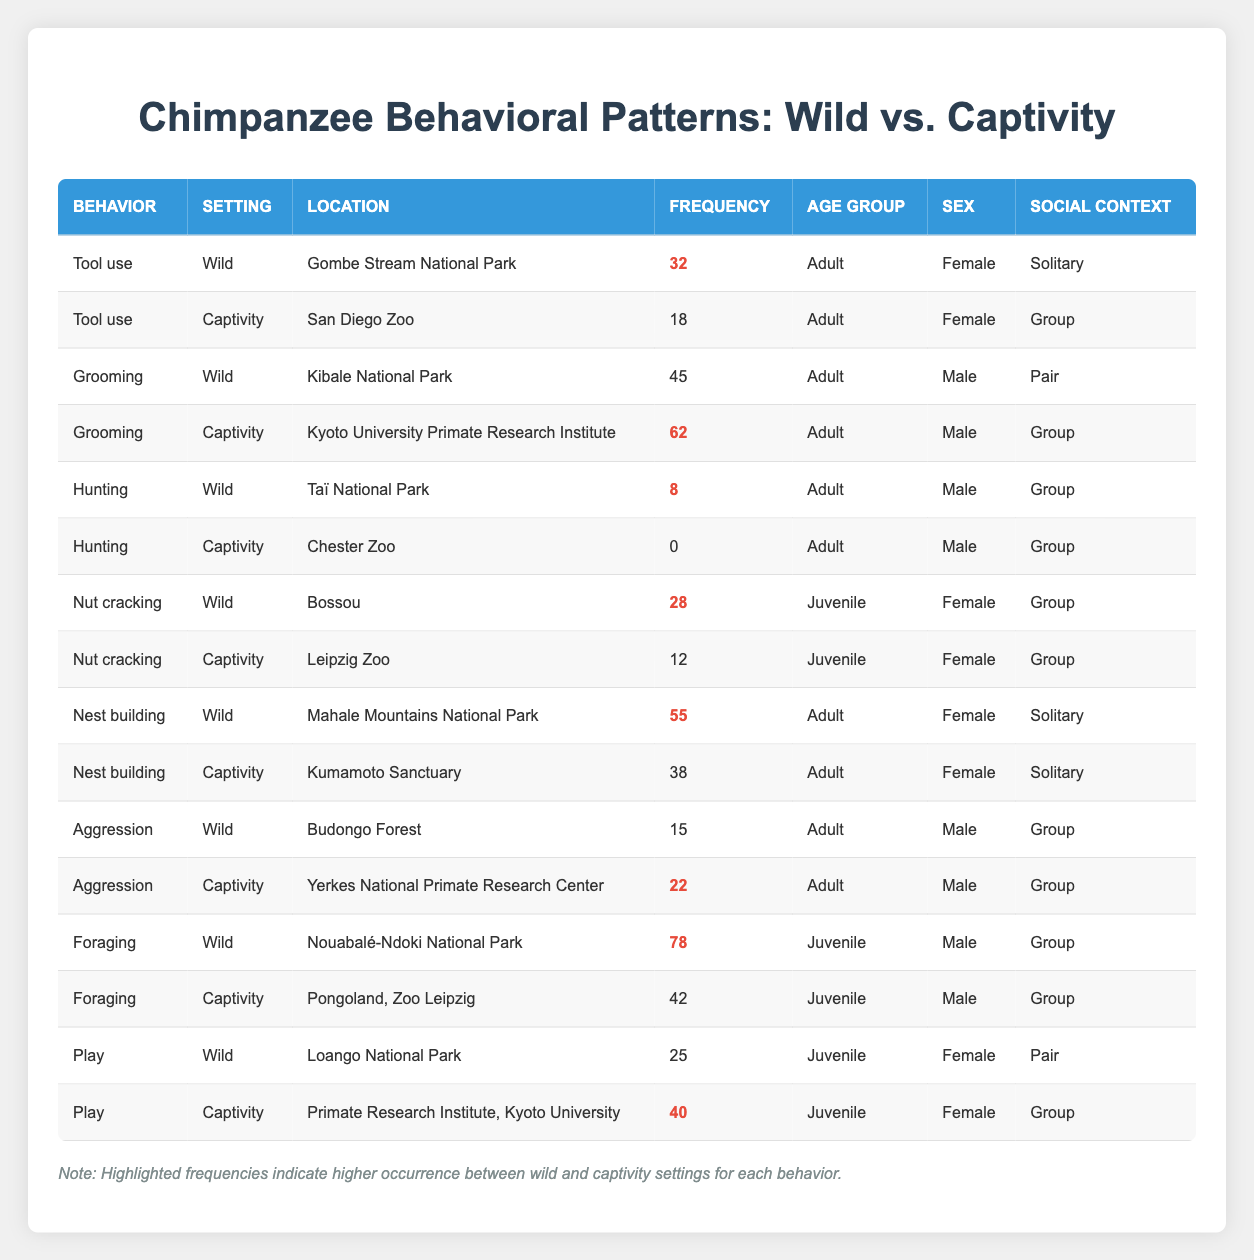What is the frequency of grooming behaviors in captivity for adult males? In the table under the "Grooming" behavior for captivity, the frequency for adult males is listed as 62.
Answer: 62 How many behaviors in captivity have a frequency greater than 40? By examining the table, the behaviors in captivity with frequencies greater than 40 are Grooming (62), Foraging (42), and Play (40). That gives us a total of 3 behaviors.
Answer: 3 Is tool use behavior more frequent in wild settings than in captivity for female adults? From the table, tool use in the wild occurs 32 times, while in captivity, it is 18 times. Therefore, tool use is indeed more frequent in the wild.
Answer: Yes What is the difference in frequency of aggression between wild and captivity settings for adult males? In the wild, aggression behavior occurs 15 times, while it occurs 22 times in captivity. The difference is calculated as 22 - 15 = 7.
Answer: 7 What is the average frequency of nut cracking in wild settings compared to captivity for juvenile females? In the wild, nut cracking frequency is 28, while in captivity it is 12. The average for both settings is calculated as (28 + 12) / 2 = 20.
Answer: 20 Which setting shows a higher frequency for nest building behavior overall? Nest building frequency in the wild is 55 and in captivity, it is 38. Since 55 (wild) is greater than 38 (captivity), the wild setting shows higher frequency.
Answer: Wild How does the frequency of play in captivity compare to that in wild settings? In the wild, the frequency for play is 25, and in captivity, it is 40. Since 40 (captivity) is greater than 25 (wild), play behavior is more frequent in captivity.
Answer: Captivity Is foraging behavior more common in juveniles than adults in wild settings? Foraging frequency for juveniles in the wild is 78, whereas there are no entries for adult foraging behavior listed in the wild from the table. Thus, it is indeed more frequent for juveniles.
Answer: Yes What behavior has the highest recorded frequency in the wild setting? The highest recorded frequency in the wild is foraging at 78 occurrences as noted in the table under the wild section.
Answer: Foraging 